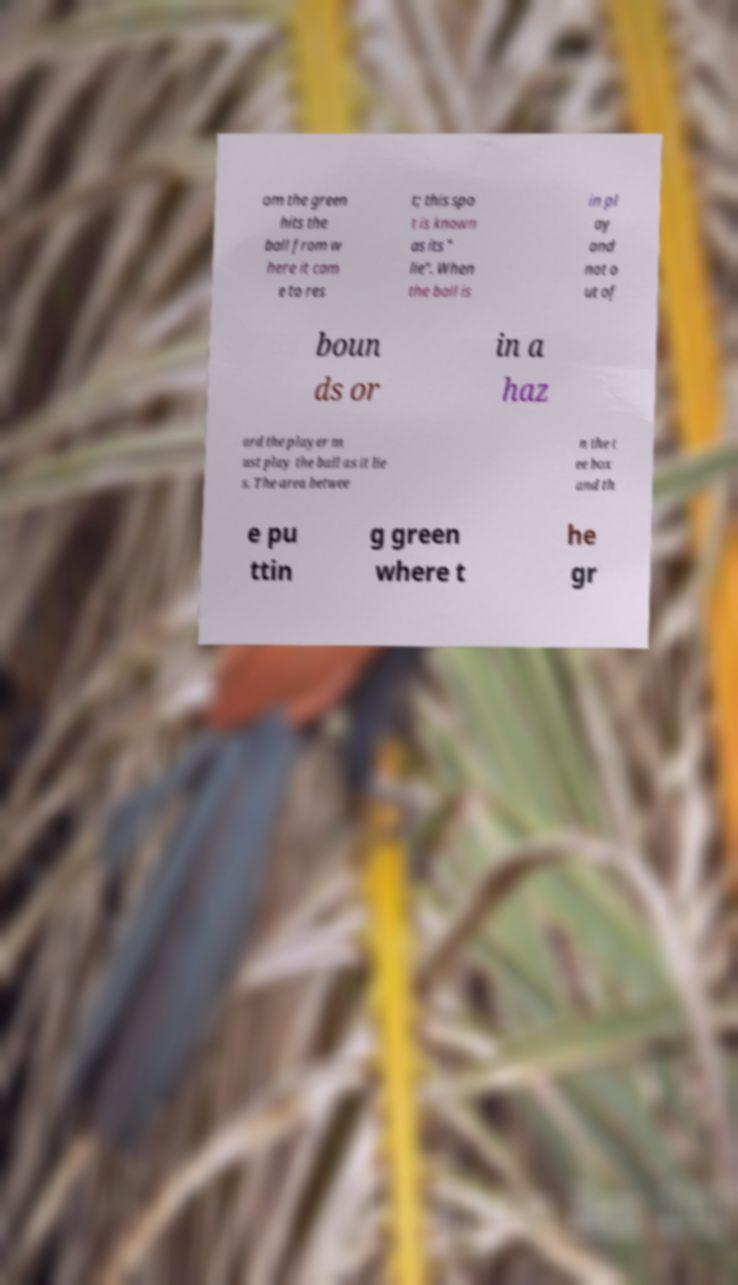Could you assist in decoding the text presented in this image and type it out clearly? om the green hits the ball from w here it cam e to res t; this spo t is known as its " lie". When the ball is in pl ay and not o ut of boun ds or in a haz ard the player m ust play the ball as it lie s. The area betwee n the t ee box and th e pu ttin g green where t he gr 